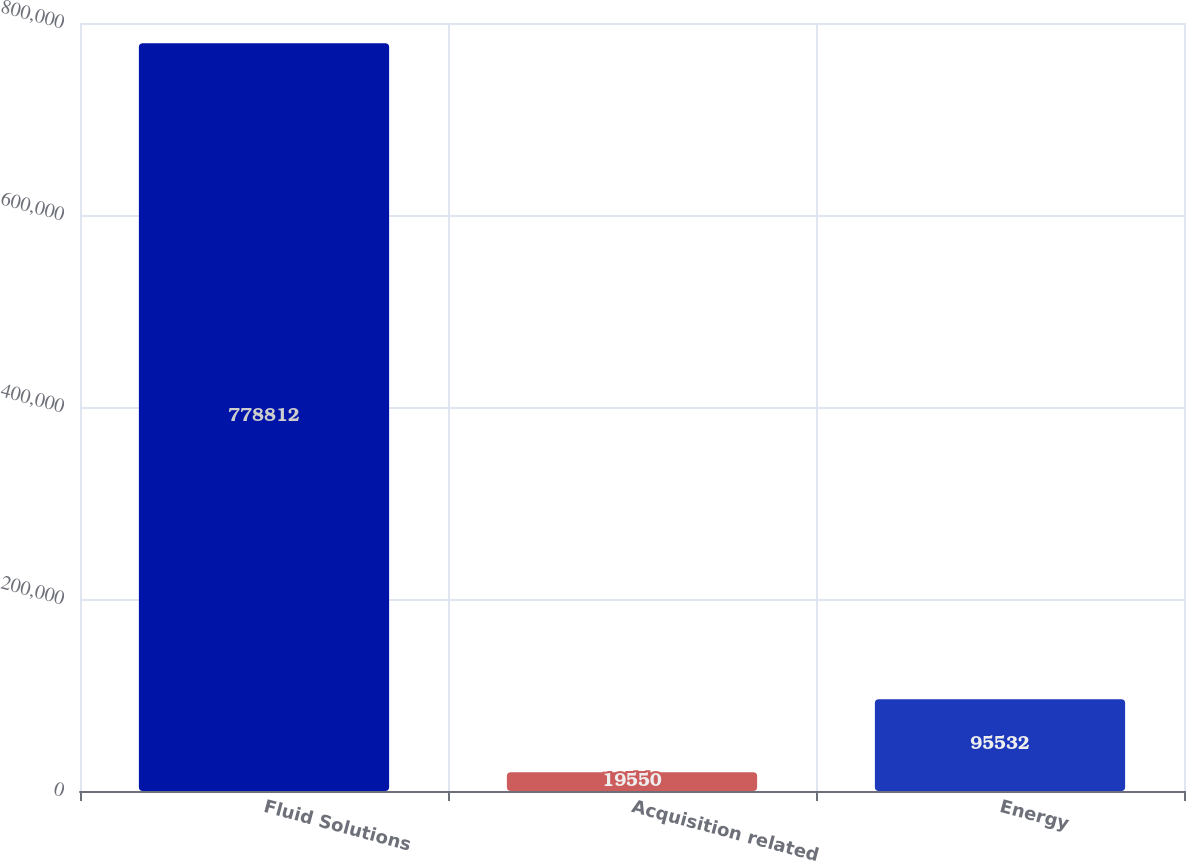<chart> <loc_0><loc_0><loc_500><loc_500><bar_chart><fcel>Fluid Solutions<fcel>Acquisition related<fcel>Energy<nl><fcel>778812<fcel>19550<fcel>95532<nl></chart> 